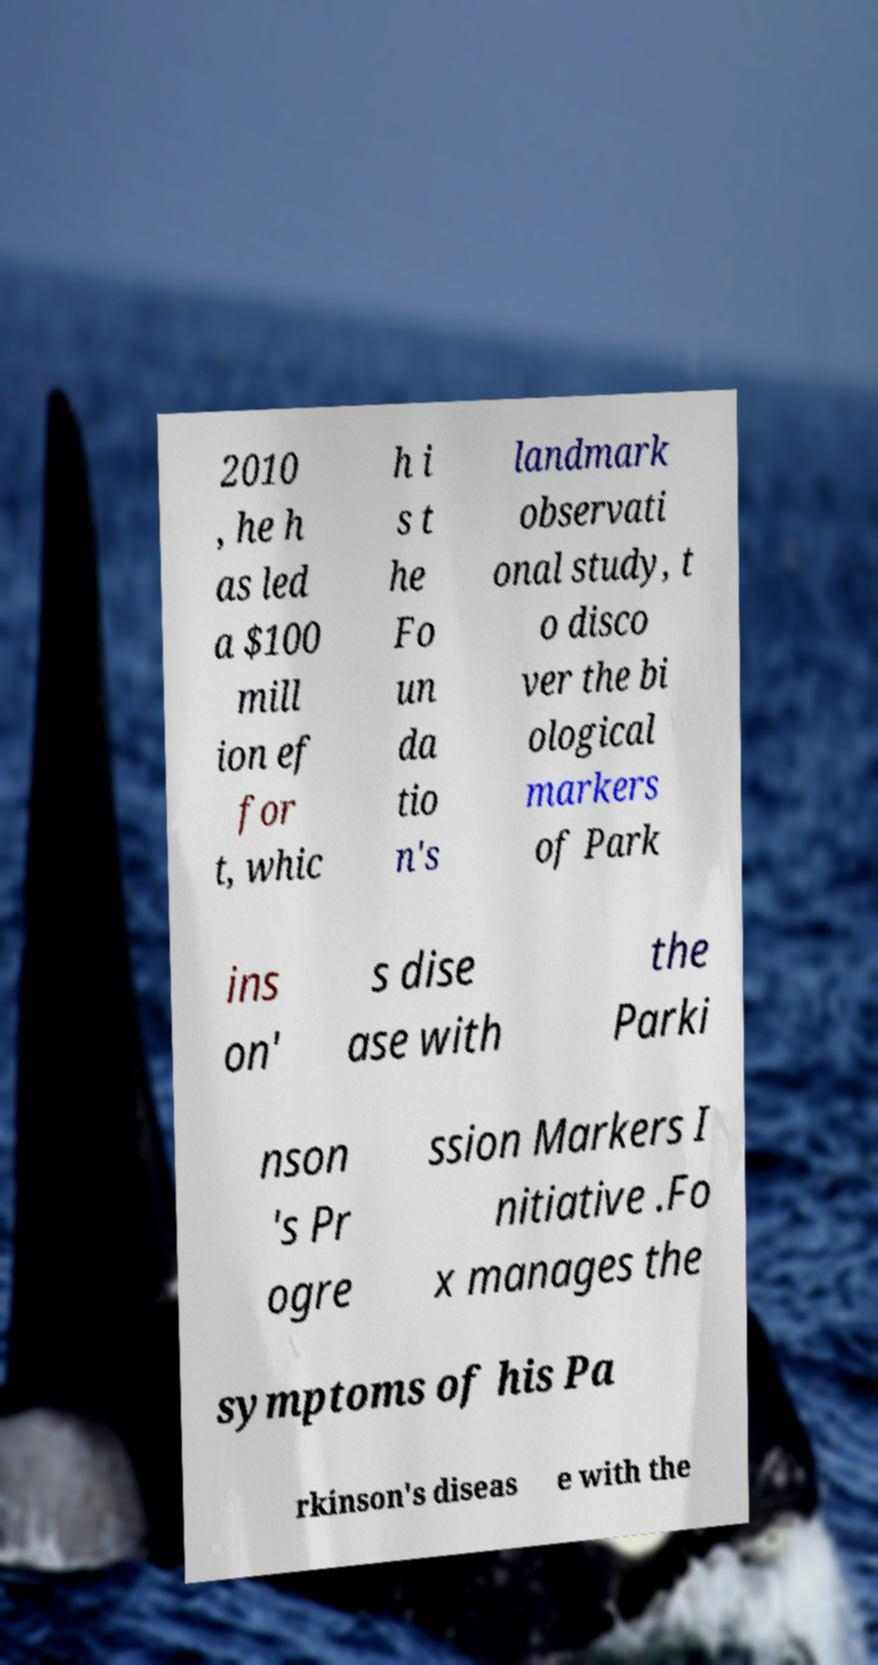Could you extract and type out the text from this image? 2010 , he h as led a $100 mill ion ef for t, whic h i s t he Fo un da tio n's landmark observati onal study, t o disco ver the bi ological markers of Park ins on' s dise ase with the Parki nson 's Pr ogre ssion Markers I nitiative .Fo x manages the symptoms of his Pa rkinson's diseas e with the 